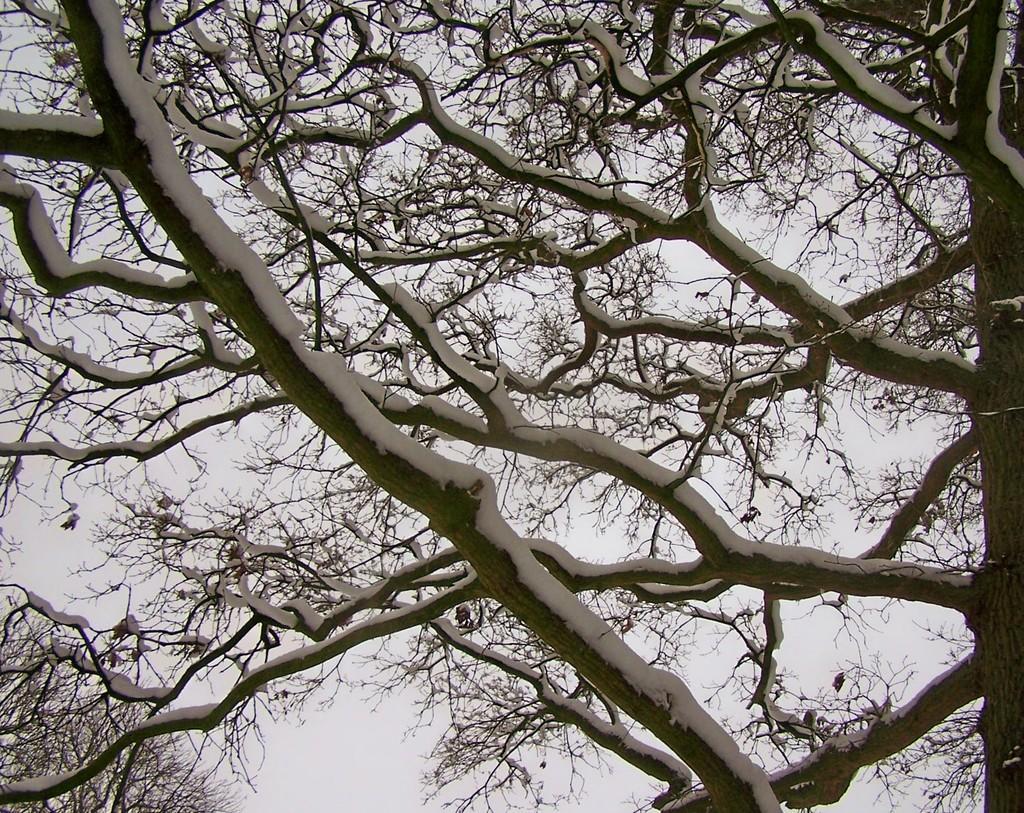Please provide a concise description of this image. In this image we can see trees covered with snow and sky. 